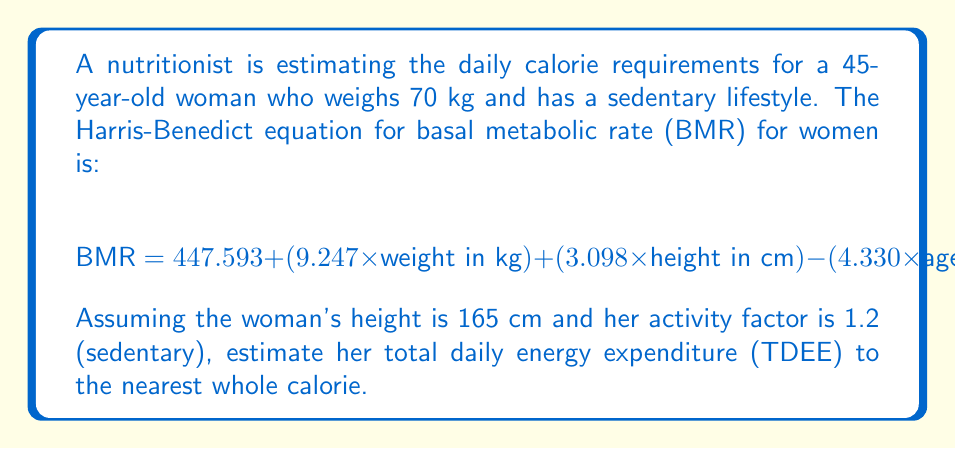Give your solution to this math problem. To solve this problem, we'll follow these steps:

1. Calculate the BMR using the given Harris-Benedict equation.
2. Multiply the BMR by the activity factor to get the TDEE.
3. Round the result to the nearest whole calorie.

Step 1: Calculate BMR
$$ \begin{align}
\text{BMR} &= 447.593 + (9.247 \times 70) + (3.098 \times 165) - (4.330 \times 45) \\
&= 447.593 + 647.29 + 511.17 - 194.85 \\
&= 1411.203 \text{ calories}
\end{align} $$

Step 2: Calculate TDEE
$$ \begin{align}
\text{TDEE} &= \text{BMR} \times \text{Activity Factor} \\
&= 1411.203 \times 1.2 \\
&= 1693.4436 \text{ calories}
\end{align} $$

Step 3: Round to the nearest whole calorie
$1693.4436$ rounds to $1693$ calories.
Answer: 1693 calories 